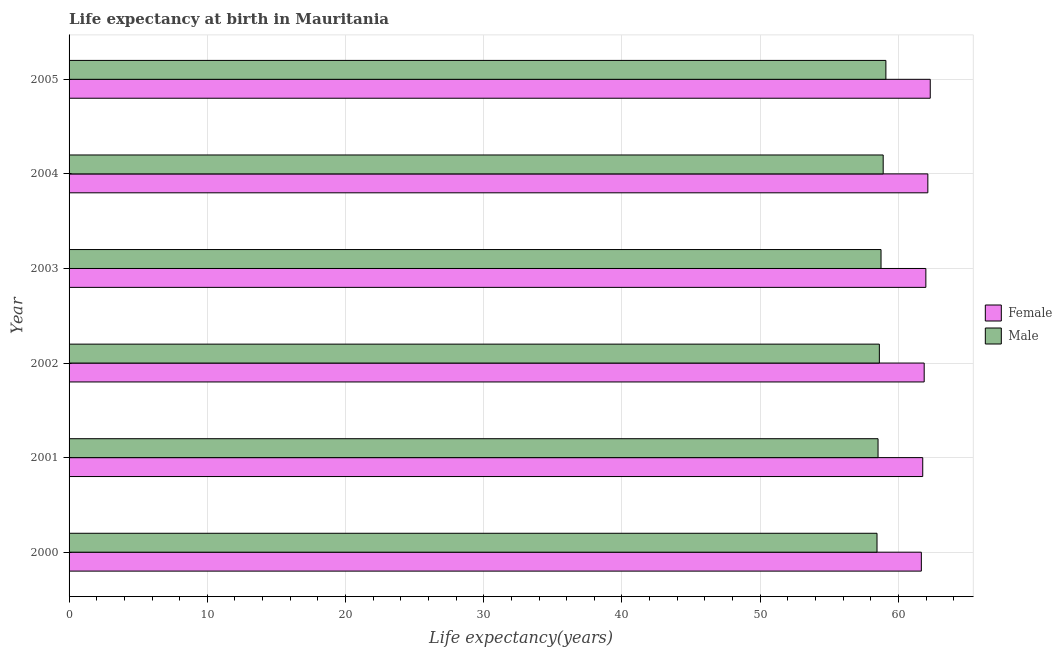How many different coloured bars are there?
Your answer should be very brief. 2. How many groups of bars are there?
Ensure brevity in your answer.  6. Are the number of bars on each tick of the Y-axis equal?
Your answer should be compact. Yes. How many bars are there on the 6th tick from the bottom?
Ensure brevity in your answer.  2. In how many cases, is the number of bars for a given year not equal to the number of legend labels?
Ensure brevity in your answer.  0. What is the life expectancy(female) in 2002?
Offer a terse response. 61.87. Across all years, what is the maximum life expectancy(male)?
Provide a succinct answer. 59.09. Across all years, what is the minimum life expectancy(male)?
Your response must be concise. 58.45. What is the total life expectancy(female) in the graph?
Your response must be concise. 371.71. What is the difference between the life expectancy(male) in 2000 and that in 2003?
Your answer should be compact. -0.29. What is the difference between the life expectancy(female) in 2002 and the life expectancy(male) in 2000?
Your answer should be very brief. 3.41. What is the average life expectancy(female) per year?
Ensure brevity in your answer.  61.95. In the year 2005, what is the difference between the life expectancy(male) and life expectancy(female)?
Provide a succinct answer. -3.21. What is the ratio of the life expectancy(male) in 2001 to that in 2005?
Make the answer very short. 0.99. What is the difference between the highest and the second highest life expectancy(male)?
Your response must be concise. 0.2. What is the difference between the highest and the lowest life expectancy(male)?
Offer a terse response. 0.64. What does the 2nd bar from the bottom in 2005 represents?
Your answer should be very brief. Male. How many bars are there?
Your response must be concise. 12. How many years are there in the graph?
Your answer should be very brief. 6. Does the graph contain grids?
Keep it short and to the point. Yes. Where does the legend appear in the graph?
Offer a very short reply. Center right. What is the title of the graph?
Your answer should be very brief. Life expectancy at birth in Mauritania. Does "Personal remittances" appear as one of the legend labels in the graph?
Your response must be concise. No. What is the label or title of the X-axis?
Give a very brief answer. Life expectancy(years). What is the label or title of the Y-axis?
Keep it short and to the point. Year. What is the Life expectancy(years) in Female in 2000?
Your response must be concise. 61.66. What is the Life expectancy(years) of Male in 2000?
Offer a terse response. 58.45. What is the Life expectancy(years) of Female in 2001?
Your answer should be compact. 61.76. What is the Life expectancy(years) in Male in 2001?
Your response must be concise. 58.53. What is the Life expectancy(years) in Female in 2002?
Offer a very short reply. 61.87. What is the Life expectancy(years) in Male in 2002?
Offer a terse response. 58.62. What is the Life expectancy(years) in Female in 2003?
Your answer should be very brief. 61.99. What is the Life expectancy(years) in Male in 2003?
Make the answer very short. 58.74. What is the Life expectancy(years) of Female in 2004?
Provide a short and direct response. 62.13. What is the Life expectancy(years) of Male in 2004?
Your answer should be compact. 58.9. What is the Life expectancy(years) of Female in 2005?
Your answer should be compact. 62.3. What is the Life expectancy(years) in Male in 2005?
Offer a very short reply. 59.09. Across all years, what is the maximum Life expectancy(years) of Female?
Offer a very short reply. 62.3. Across all years, what is the maximum Life expectancy(years) in Male?
Keep it short and to the point. 59.09. Across all years, what is the minimum Life expectancy(years) of Female?
Provide a succinct answer. 61.66. Across all years, what is the minimum Life expectancy(years) of Male?
Keep it short and to the point. 58.45. What is the total Life expectancy(years) in Female in the graph?
Your answer should be compact. 371.71. What is the total Life expectancy(years) of Male in the graph?
Your response must be concise. 352.34. What is the difference between the Life expectancy(years) of Female in 2000 and that in 2001?
Offer a terse response. -0.1. What is the difference between the Life expectancy(years) of Male in 2000 and that in 2001?
Ensure brevity in your answer.  -0.07. What is the difference between the Life expectancy(years) in Female in 2000 and that in 2002?
Provide a short and direct response. -0.21. What is the difference between the Life expectancy(years) of Male in 2000 and that in 2002?
Offer a very short reply. -0.17. What is the difference between the Life expectancy(years) of Female in 2000 and that in 2003?
Provide a succinct answer. -0.33. What is the difference between the Life expectancy(years) in Male in 2000 and that in 2003?
Make the answer very short. -0.29. What is the difference between the Life expectancy(years) of Female in 2000 and that in 2004?
Make the answer very short. -0.47. What is the difference between the Life expectancy(years) of Male in 2000 and that in 2004?
Your response must be concise. -0.45. What is the difference between the Life expectancy(years) in Female in 2000 and that in 2005?
Your answer should be compact. -0.64. What is the difference between the Life expectancy(years) of Male in 2000 and that in 2005?
Provide a succinct answer. -0.64. What is the difference between the Life expectancy(years) of Female in 2001 and that in 2002?
Provide a succinct answer. -0.1. What is the difference between the Life expectancy(years) of Male in 2001 and that in 2002?
Provide a succinct answer. -0.09. What is the difference between the Life expectancy(years) in Female in 2001 and that in 2003?
Offer a very short reply. -0.23. What is the difference between the Life expectancy(years) of Male in 2001 and that in 2003?
Provide a succinct answer. -0.21. What is the difference between the Life expectancy(years) of Female in 2001 and that in 2004?
Your answer should be compact. -0.37. What is the difference between the Life expectancy(years) of Male in 2001 and that in 2004?
Provide a short and direct response. -0.37. What is the difference between the Life expectancy(years) of Female in 2001 and that in 2005?
Offer a terse response. -0.54. What is the difference between the Life expectancy(years) in Male in 2001 and that in 2005?
Ensure brevity in your answer.  -0.57. What is the difference between the Life expectancy(years) in Female in 2002 and that in 2003?
Make the answer very short. -0.12. What is the difference between the Life expectancy(years) of Male in 2002 and that in 2003?
Your answer should be compact. -0.12. What is the difference between the Life expectancy(years) in Female in 2002 and that in 2004?
Offer a very short reply. -0.26. What is the difference between the Life expectancy(years) of Male in 2002 and that in 2004?
Keep it short and to the point. -0.28. What is the difference between the Life expectancy(years) in Female in 2002 and that in 2005?
Provide a short and direct response. -0.44. What is the difference between the Life expectancy(years) in Male in 2002 and that in 2005?
Keep it short and to the point. -0.47. What is the difference between the Life expectancy(years) in Female in 2003 and that in 2004?
Your response must be concise. -0.14. What is the difference between the Life expectancy(years) of Male in 2003 and that in 2004?
Provide a short and direct response. -0.16. What is the difference between the Life expectancy(years) of Female in 2003 and that in 2005?
Offer a very short reply. -0.32. What is the difference between the Life expectancy(years) of Male in 2003 and that in 2005?
Provide a short and direct response. -0.35. What is the difference between the Life expectancy(years) of Female in 2004 and that in 2005?
Provide a short and direct response. -0.17. What is the difference between the Life expectancy(years) in Male in 2004 and that in 2005?
Provide a succinct answer. -0.2. What is the difference between the Life expectancy(years) in Female in 2000 and the Life expectancy(years) in Male in 2001?
Your answer should be compact. 3.13. What is the difference between the Life expectancy(years) of Female in 2000 and the Life expectancy(years) of Male in 2002?
Offer a very short reply. 3.04. What is the difference between the Life expectancy(years) in Female in 2000 and the Life expectancy(years) in Male in 2003?
Your answer should be compact. 2.92. What is the difference between the Life expectancy(years) of Female in 2000 and the Life expectancy(years) of Male in 2004?
Provide a succinct answer. 2.76. What is the difference between the Life expectancy(years) of Female in 2000 and the Life expectancy(years) of Male in 2005?
Provide a short and direct response. 2.56. What is the difference between the Life expectancy(years) in Female in 2001 and the Life expectancy(years) in Male in 2002?
Ensure brevity in your answer.  3.14. What is the difference between the Life expectancy(years) in Female in 2001 and the Life expectancy(years) in Male in 2003?
Give a very brief answer. 3.02. What is the difference between the Life expectancy(years) of Female in 2001 and the Life expectancy(years) of Male in 2004?
Your response must be concise. 2.86. What is the difference between the Life expectancy(years) of Female in 2001 and the Life expectancy(years) of Male in 2005?
Give a very brief answer. 2.67. What is the difference between the Life expectancy(years) of Female in 2002 and the Life expectancy(years) of Male in 2003?
Ensure brevity in your answer.  3.12. What is the difference between the Life expectancy(years) of Female in 2002 and the Life expectancy(years) of Male in 2004?
Keep it short and to the point. 2.97. What is the difference between the Life expectancy(years) in Female in 2002 and the Life expectancy(years) in Male in 2005?
Keep it short and to the point. 2.77. What is the difference between the Life expectancy(years) of Female in 2003 and the Life expectancy(years) of Male in 2004?
Your response must be concise. 3.09. What is the difference between the Life expectancy(years) of Female in 2003 and the Life expectancy(years) of Male in 2005?
Keep it short and to the point. 2.89. What is the difference between the Life expectancy(years) in Female in 2004 and the Life expectancy(years) in Male in 2005?
Make the answer very short. 3.04. What is the average Life expectancy(years) of Female per year?
Make the answer very short. 61.95. What is the average Life expectancy(years) in Male per year?
Your response must be concise. 58.72. In the year 2000, what is the difference between the Life expectancy(years) in Female and Life expectancy(years) in Male?
Ensure brevity in your answer.  3.21. In the year 2001, what is the difference between the Life expectancy(years) in Female and Life expectancy(years) in Male?
Your answer should be compact. 3.23. In the year 2002, what is the difference between the Life expectancy(years) in Female and Life expectancy(years) in Male?
Provide a succinct answer. 3.24. In the year 2003, what is the difference between the Life expectancy(years) in Female and Life expectancy(years) in Male?
Your answer should be very brief. 3.24. In the year 2004, what is the difference between the Life expectancy(years) of Female and Life expectancy(years) of Male?
Your answer should be compact. 3.23. In the year 2005, what is the difference between the Life expectancy(years) of Female and Life expectancy(years) of Male?
Give a very brief answer. 3.21. What is the ratio of the Life expectancy(years) in Male in 2000 to that in 2001?
Your answer should be very brief. 1. What is the ratio of the Life expectancy(years) in Female in 2000 to that in 2002?
Ensure brevity in your answer.  1. What is the ratio of the Life expectancy(years) of Female in 2000 to that in 2004?
Offer a very short reply. 0.99. What is the ratio of the Life expectancy(years) in Male in 2000 to that in 2005?
Your answer should be compact. 0.99. What is the ratio of the Life expectancy(years) in Male in 2001 to that in 2002?
Ensure brevity in your answer.  1. What is the ratio of the Life expectancy(years) in Female in 2001 to that in 2003?
Your answer should be compact. 1. What is the ratio of the Life expectancy(years) of Male in 2001 to that in 2003?
Provide a short and direct response. 1. What is the ratio of the Life expectancy(years) of Female in 2001 to that in 2004?
Provide a short and direct response. 0.99. What is the ratio of the Life expectancy(years) of Female in 2001 to that in 2005?
Make the answer very short. 0.99. What is the ratio of the Life expectancy(years) in Female in 2002 to that in 2003?
Provide a short and direct response. 1. What is the ratio of the Life expectancy(years) of Male in 2002 to that in 2004?
Offer a terse response. 1. What is the ratio of the Life expectancy(years) in Female in 2002 to that in 2005?
Offer a terse response. 0.99. What is the ratio of the Life expectancy(years) in Male in 2002 to that in 2005?
Ensure brevity in your answer.  0.99. What is the ratio of the Life expectancy(years) of Male in 2003 to that in 2005?
Your answer should be very brief. 0.99. What is the ratio of the Life expectancy(years) of Female in 2004 to that in 2005?
Make the answer very short. 1. What is the difference between the highest and the second highest Life expectancy(years) in Female?
Offer a very short reply. 0.17. What is the difference between the highest and the second highest Life expectancy(years) in Male?
Give a very brief answer. 0.2. What is the difference between the highest and the lowest Life expectancy(years) in Female?
Make the answer very short. 0.64. What is the difference between the highest and the lowest Life expectancy(years) in Male?
Offer a terse response. 0.64. 